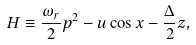Convert formula to latex. <formula><loc_0><loc_0><loc_500><loc_500>H \equiv \frac { \omega _ { r } } { 2 } p ^ { 2 } - u \cos x - \frac { \Delta } { 2 } z ,</formula> 